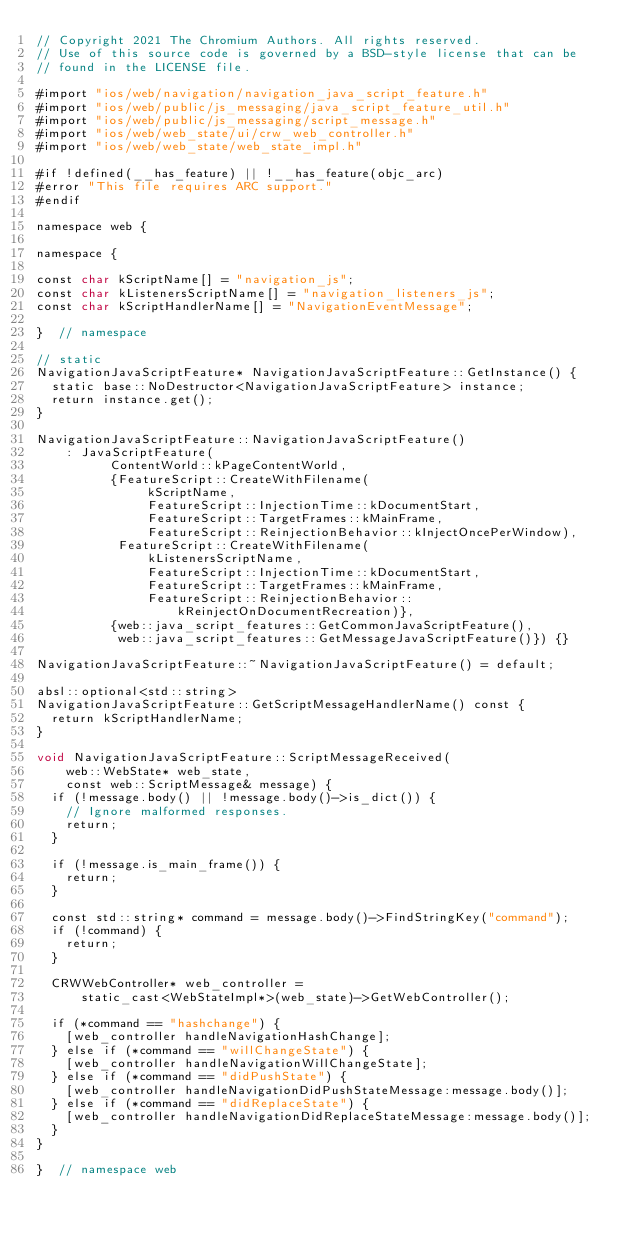<code> <loc_0><loc_0><loc_500><loc_500><_ObjectiveC_>// Copyright 2021 The Chromium Authors. All rights reserved.
// Use of this source code is governed by a BSD-style license that can be
// found in the LICENSE file.

#import "ios/web/navigation/navigation_java_script_feature.h"
#import "ios/web/public/js_messaging/java_script_feature_util.h"
#import "ios/web/public/js_messaging/script_message.h"
#import "ios/web/web_state/ui/crw_web_controller.h"
#import "ios/web/web_state/web_state_impl.h"

#if !defined(__has_feature) || !__has_feature(objc_arc)
#error "This file requires ARC support."
#endif

namespace web {

namespace {

const char kScriptName[] = "navigation_js";
const char kListenersScriptName[] = "navigation_listeners_js";
const char kScriptHandlerName[] = "NavigationEventMessage";

}  // namespace

// static
NavigationJavaScriptFeature* NavigationJavaScriptFeature::GetInstance() {
  static base::NoDestructor<NavigationJavaScriptFeature> instance;
  return instance.get();
}

NavigationJavaScriptFeature::NavigationJavaScriptFeature()
    : JavaScriptFeature(
          ContentWorld::kPageContentWorld,
          {FeatureScript::CreateWithFilename(
               kScriptName,
               FeatureScript::InjectionTime::kDocumentStart,
               FeatureScript::TargetFrames::kMainFrame,
               FeatureScript::ReinjectionBehavior::kInjectOncePerWindow),
           FeatureScript::CreateWithFilename(
               kListenersScriptName,
               FeatureScript::InjectionTime::kDocumentStart,
               FeatureScript::TargetFrames::kMainFrame,
               FeatureScript::ReinjectionBehavior::
                   kReinjectOnDocumentRecreation)},
          {web::java_script_features::GetCommonJavaScriptFeature(),
           web::java_script_features::GetMessageJavaScriptFeature()}) {}

NavigationJavaScriptFeature::~NavigationJavaScriptFeature() = default;

absl::optional<std::string>
NavigationJavaScriptFeature::GetScriptMessageHandlerName() const {
  return kScriptHandlerName;
}

void NavigationJavaScriptFeature::ScriptMessageReceived(
    web::WebState* web_state,
    const web::ScriptMessage& message) {
  if (!message.body() || !message.body()->is_dict()) {
    // Ignore malformed responses.
    return;
  }

  if (!message.is_main_frame()) {
    return;
  }

  const std::string* command = message.body()->FindStringKey("command");
  if (!command) {
    return;
  }

  CRWWebController* web_controller =
      static_cast<WebStateImpl*>(web_state)->GetWebController();

  if (*command == "hashchange") {
    [web_controller handleNavigationHashChange];
  } else if (*command == "willChangeState") {
    [web_controller handleNavigationWillChangeState];
  } else if (*command == "didPushState") {
    [web_controller handleNavigationDidPushStateMessage:message.body()];
  } else if (*command == "didReplaceState") {
    [web_controller handleNavigationDidReplaceStateMessage:message.body()];
  }
}

}  // namespace web
</code> 